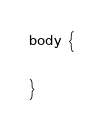Convert code to text. <code><loc_0><loc_0><loc_500><loc_500><_CSS_>body {

}</code> 